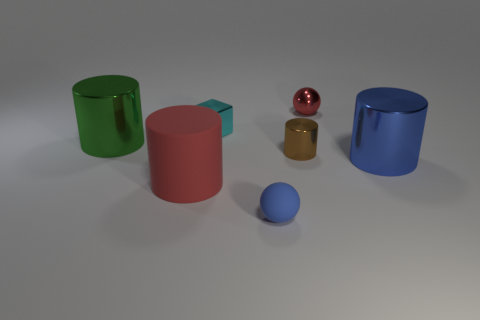There is a ball that is in front of the large cylinder that is behind the big cylinder that is to the right of the red sphere; what is its material?
Make the answer very short. Rubber. Do the shiny block and the shiny object that is in front of the small brown metallic cylinder have the same color?
Your response must be concise. No. What number of objects are tiny balls that are in front of the big blue metallic thing or cylinders that are right of the blue rubber thing?
Your answer should be compact. 3. The large matte object that is on the left side of the cylinder that is on the right side of the tiny red shiny sphere is what shape?
Make the answer very short. Cylinder. Are there any big blue objects made of the same material as the tiny red ball?
Provide a succinct answer. Yes. There is a small metal object that is the same shape as the large matte thing; what color is it?
Make the answer very short. Brown. Are there fewer tiny metallic cylinders right of the blue metallic cylinder than big shiny things in front of the small cylinder?
Make the answer very short. Yes. How many other things are there of the same shape as the brown metal object?
Make the answer very short. 3. Is the number of small cyan blocks in front of the tiny brown shiny object less than the number of tiny brown metallic cylinders?
Offer a terse response. Yes. There is a blue object to the right of the small red metal thing; what is its material?
Your answer should be very brief. Metal. 